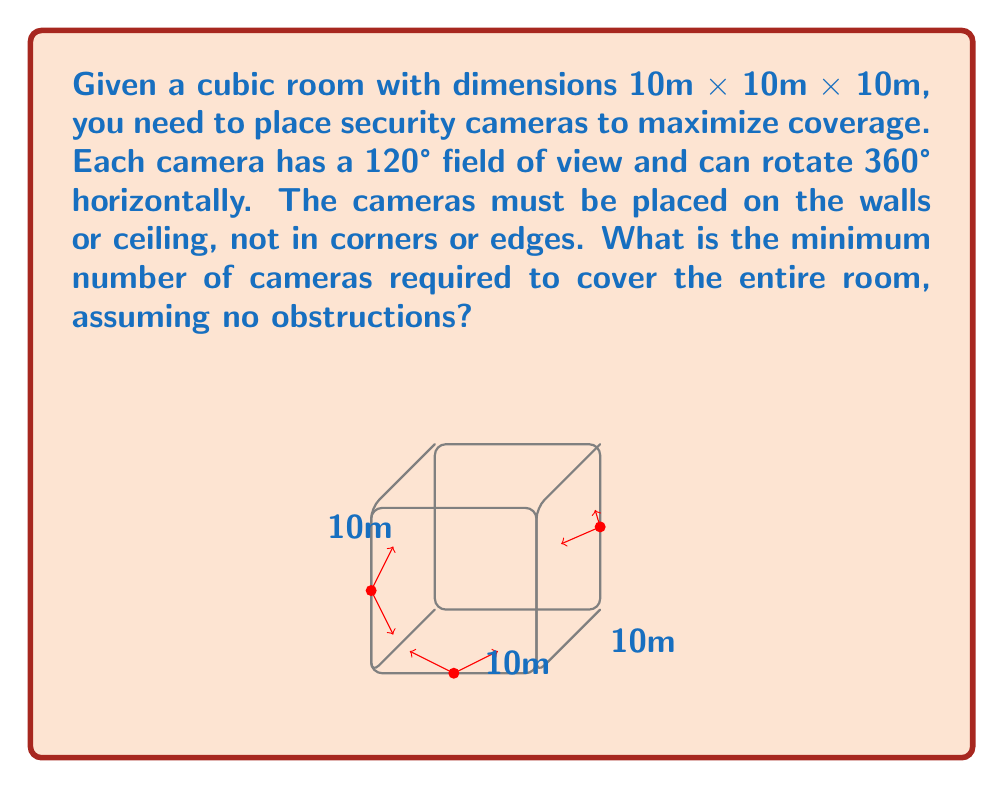Could you help me with this problem? To solve this problem, we need to consider the geometry of the room and the coverage of each camera:

1) First, let's consider the field of view (FOV) of each camera:
   - 120° vertical FOV
   - 360° horizontal rotation

2) In a cube, we need to cover all six faces. Due to the camera's FOV, each camera can effectively cover more than one face partially.

3) Let's analyze the coverage:
   - A camera placed in the center of a face can cover that entire face and partially cover the four adjacent faces.
   - The 120° FOV allows the camera to see halfway into each adjacent face.

4) Mathematically, if we place a camera at the center of a face:
   $$\tan(60°) = \frac{\text{half of face length}}{\text{face length}} = \frac{5m}{10m} = 0.5$$
   This confirms that a camera can see halfway into adjacent faces.

5) Given this coverage pattern, we can cover the entire cube with just three cameras:
   - One on the ceiling, covering the top face and half of all side faces
   - One on the middle of a side wall, covering that face and half of the remaining uncovered areas
   - One on the opposite wall, covering the last face and the remaining uncovered areas

6) This configuration ensures that every point in the cube is visible to at least one camera.

Therefore, the minimum number of cameras required is 3.
Answer: 3 cameras 